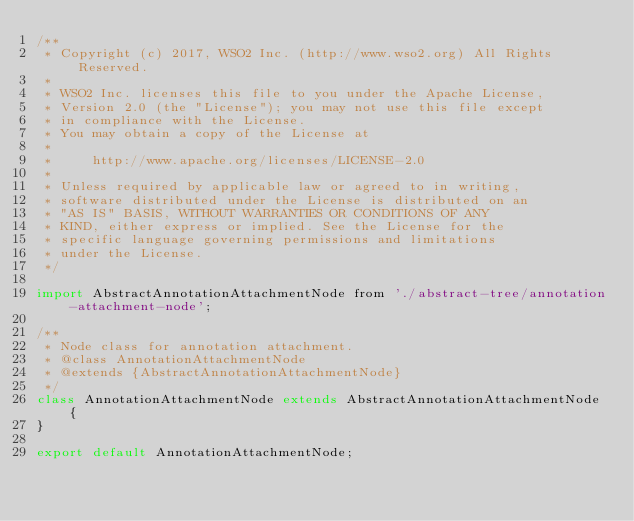<code> <loc_0><loc_0><loc_500><loc_500><_JavaScript_>/**
 * Copyright (c) 2017, WSO2 Inc. (http://www.wso2.org) All Rights Reserved.
 *
 * WSO2 Inc. licenses this file to you under the Apache License,
 * Version 2.0 (the "License"); you may not use this file except
 * in compliance with the License.
 * You may obtain a copy of the License at
 *
 *     http://www.apache.org/licenses/LICENSE-2.0
 *
 * Unless required by applicable law or agreed to in writing,
 * software distributed under the License is distributed on an
 * "AS IS" BASIS, WITHOUT WARRANTIES OR CONDITIONS OF ANY
 * KIND, either express or implied. See the License for the
 * specific language governing permissions and limitations
 * under the License.
 */

import AbstractAnnotationAttachmentNode from './abstract-tree/annotation-attachment-node';

/**
 * Node class for annotation attachment.
 * @class AnnotationAttachmentNode
 * @extends {AbstractAnnotationAttachmentNode}
 */
class AnnotationAttachmentNode extends AbstractAnnotationAttachmentNode {
}

export default AnnotationAttachmentNode;
</code> 